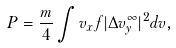<formula> <loc_0><loc_0><loc_500><loc_500>P = \frac { m } { 4 } \int v _ { x } f | \Delta v _ { y } ^ { \infty } | ^ { 2 } d v ,</formula> 